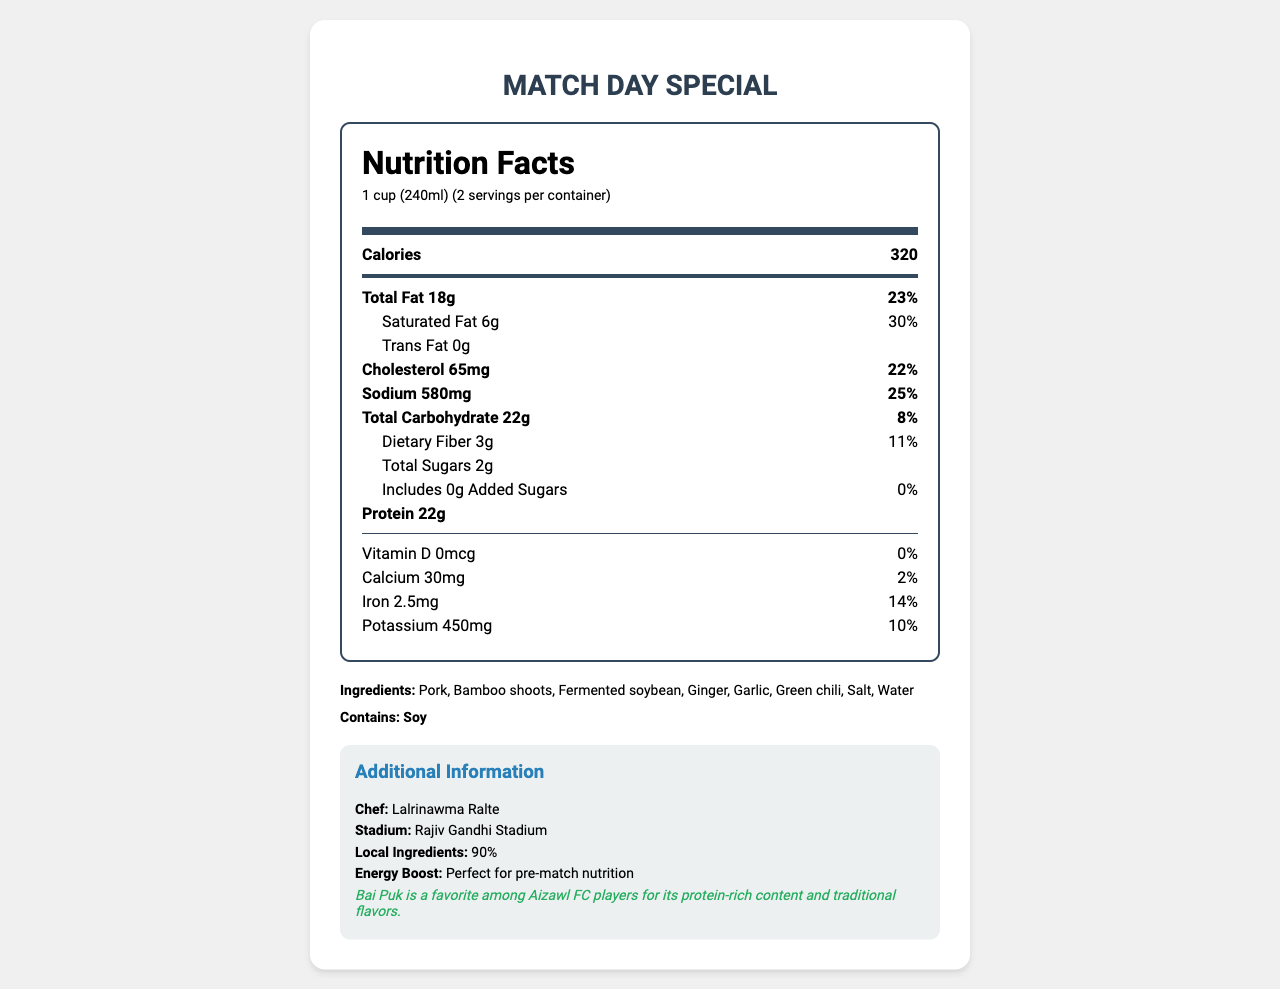what is the serving size for Bai Puk? The document states that the serving size for Bai Puk is 1 cup (240ml).
Answer: 1 cup (240ml) how many calories are in one serving of Bai Puk? The document indicates that one serving of Bai Puk contains 320 calories.
Answer: 320 what is the percentage of daily value for saturated fat in Bai Puk? The document shows that the saturated fat content provides 30% of the daily value.
Answer: 30% how much protein is in one serving of Bai Puk? The document lists the protein content as 22 grams per serving.
Answer: 22g what is the total carbohydrate content in Bai Puk? According to the document, the total carbohydrate content is 22 grams per serving.
Answer: 22g what are the primary ingredients in Bai Puk? A. Pork, Bamboo shoots, Ginger B. Pork, Fermented soybean, Water C. Pork, Bamboo shoots, Fermented soybean, Green chili D. Pork, Garlic, Green chili, Water The document lists the primary ingredients as Pork, Bamboo shoots, Fermented soybean, Green chili.
Answer: C which mineral has the highest percentage daily value in Bai Puk? A. Calcium B. Iron C. Potassium D. Sodium The document indicates that Sodium has the highest percentage daily value at 25%.
Answer: D does Bai Puk contain any allergens? The document states that Bai Puk contains soy as an allergen.
Answer: Yes is Bai Puk a match day special? The document specifically states that Bai Puk is a match day special.
Answer: Yes summarize the key nutritional aspects of Bai Puk. The document outlines the nutritional facts, ingredients, and additional information, emphasizing its suitability for match days and high protein content from local ingredients.
Answer: Bai Puk is a traditional Mizo pork stew providing 320 calories per serving, with substantial protein (22g), and significant daily values for fat, cholesterol, sodium, and dietary fiber. It has low sugars, with only 2g total sugars and 0g added sugars. It is high in local ingredients and approved for match day consumption. what percentage of local ingredients does Bai Puk contain? The document specifies that Bai Puk contains 90% local ingredients.
Answer: 90% how much Vitamin D is in Bai Puk? The document lists the Vitamin D content as 0 micrograms.
Answer: 0mcg who is the chef responsible for Bai Puk? The document names Lalrinawma Ralte as the chef for Bai Puk.
Answer: Lalrinawma Ralte what is the purpose of Bai Puk as indicated in the additional information? The additional information states that Bai Puk is a perfect source of pre-match nutrition.
Answer: Perfect for pre-match nutrition which stadium serves Bai Puk on match days? The document mentions that Bai Puk is served at Rajiv Gandhi Stadium.
Answer: Rajiv Gandhi Stadium what type of energy boost does Bai Puk provide? The document highlights Bai Puk as perfect for pre-match nutrition, indicating it provides a significant energy boost.
Answer: It is labeled as "Perfect for pre-match nutrition." who approves Bai Puk for match day consumption? The document does not provide specific information about who officially approves Bai Puk for match day consumption.
Answer: Cannot be determined explain the fun fact mentioned in the document. The document includes a fun fact stating that Bai Puk is well-liked by Aizawl FC players due to its high protein content and traditional taste.
Answer: Bai Puk is a favorite among Aizawl FC players for its protein-rich content and traditional flavors. 